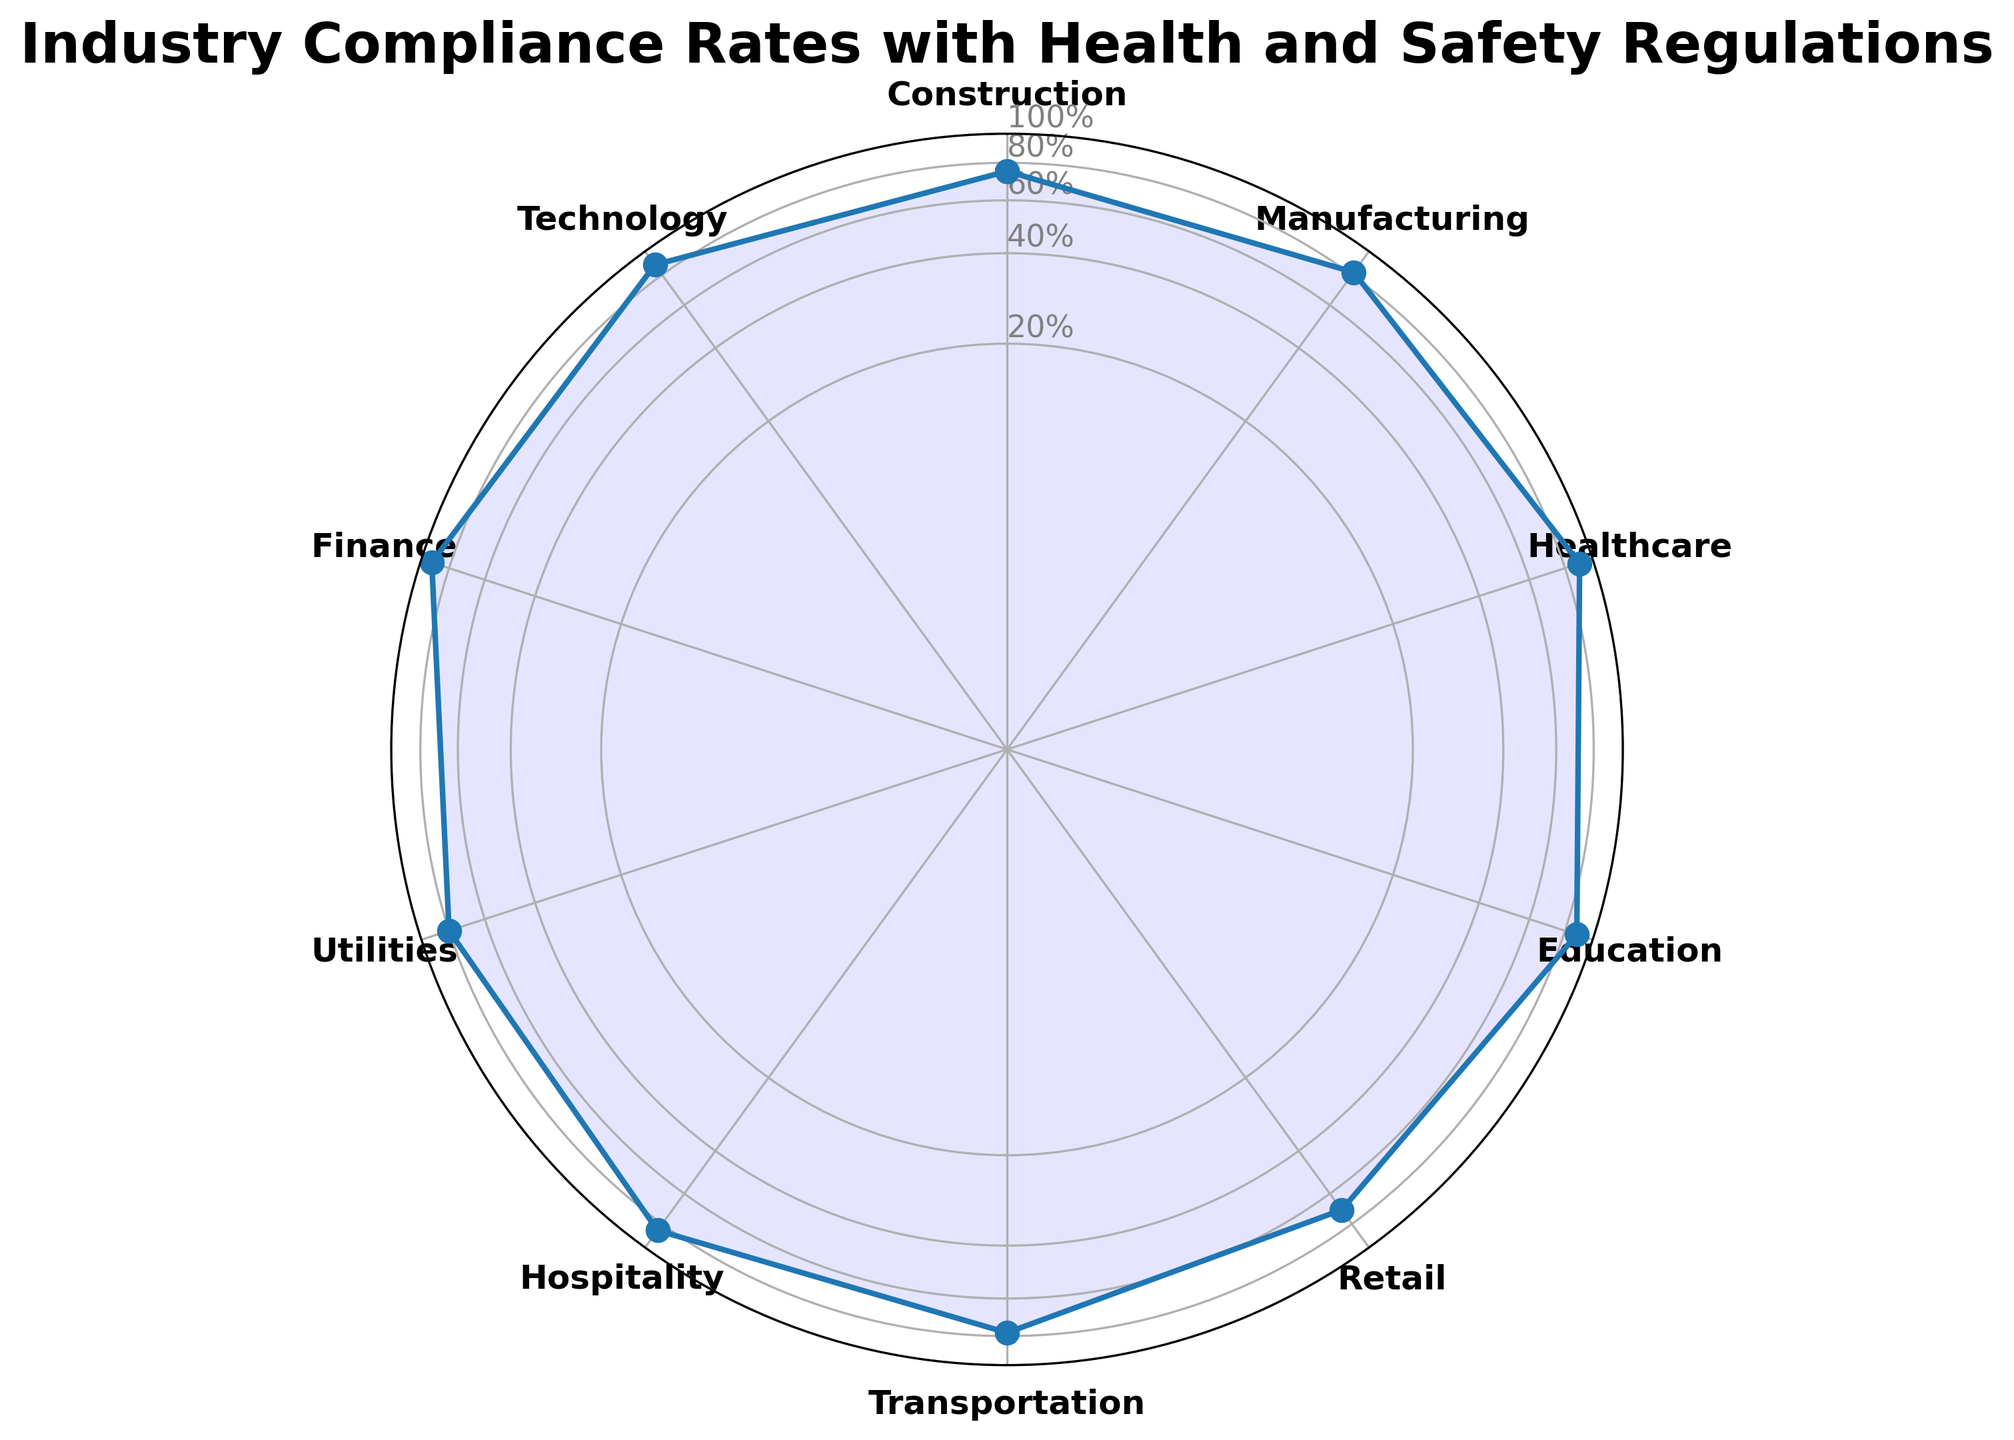What industry has the highest compliance rate? The hospitals with the highest compliance rate can be identified by observing the point that extends furthest from the center in the radar chart. This is the maximum distance from the center. In this case, the industry with the highest value, which is 92%, is Finance.
Answer: Finance What is the average compliance rate across all industries? To calculate the average compliance rate, sum all the compliance rates and divide them by the number of industries: (75 + 82 + 90 + 88 + 70 + 78 + 85 + 80 + 92 + 88) / 10 = 82.8%.
Answer: 82.8% Between Construction and Retail, which industry has a higher compliance rate? By comparing the lengths of the lines representing Construction and Retail in the chart, we see Construction is at 75% and Retail is at 70%. Therefore, Construction has a higher compliance rate.
Answer: Construction What is the difference in compliance rates between Healthcare and Transportation? Find the compliance rates for Healthcare and Transportation, which are 90% and 78%, respectively. The difference is 90% - 78% = 12%.
Answer: 12% Identify the industries with compliance rates above 80%. The industries with compliance rates above 80% are those with points outside the 80% circle. These industries are Manufacturing (82%), Healthcare (90%), Education (88%), Hospitality (85%), Finance (92%), and Technology (88%).
Answer: Manufacturing, Healthcare, Education, Hospitality, Finance, Technology Which industry has the lowest compliance rate? The industry with the lowest compliance rate is the one with the closest point to the center of the radar chart. This is Retail with a 70% compliance rate.
Answer: Retail What is the median compliance rate of the industries? To find the median, list the compliance rates in ascending order: 70, 75, 78, 80, 82, 85, 88, 88, 90, 92. As there are 10 values, the median is the average of the 5th and 6th values: (82 + 85) / 2 = 83.5%.
Answer: 83.5% How many industries have a compliance rate below 80%? Count the number of points inside the 80% circle. These are Construction (75%), Retail (70%), and Transportation (78%). There are three such industries.
Answer: 3 Which industries have a compliance rate equal to 88%? Identify the points exactly on the 88% circle. The industries with an 88% compliance rate are Education and Technology.
Answer: Education, Technology 